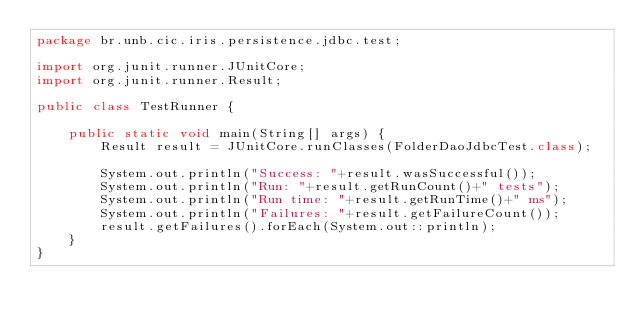Convert code to text. <code><loc_0><loc_0><loc_500><loc_500><_Java_>package br.unb.cic.iris.persistence.jdbc.test;

import org.junit.runner.JUnitCore;
import org.junit.runner.Result;

public class TestRunner {

	public static void main(String[] args) {
		Result result = JUnitCore.runClasses(FolderDaoJdbcTest.class);
		
		System.out.println("Success: "+result.wasSuccessful());
		System.out.println("Run: "+result.getRunCount()+" tests");
		System.out.println("Run time: "+result.getRunTime()+" ms");	
		System.out.println("Failures: "+result.getFailureCount());
		result.getFailures().forEach(System.out::println);
	}
}
</code> 